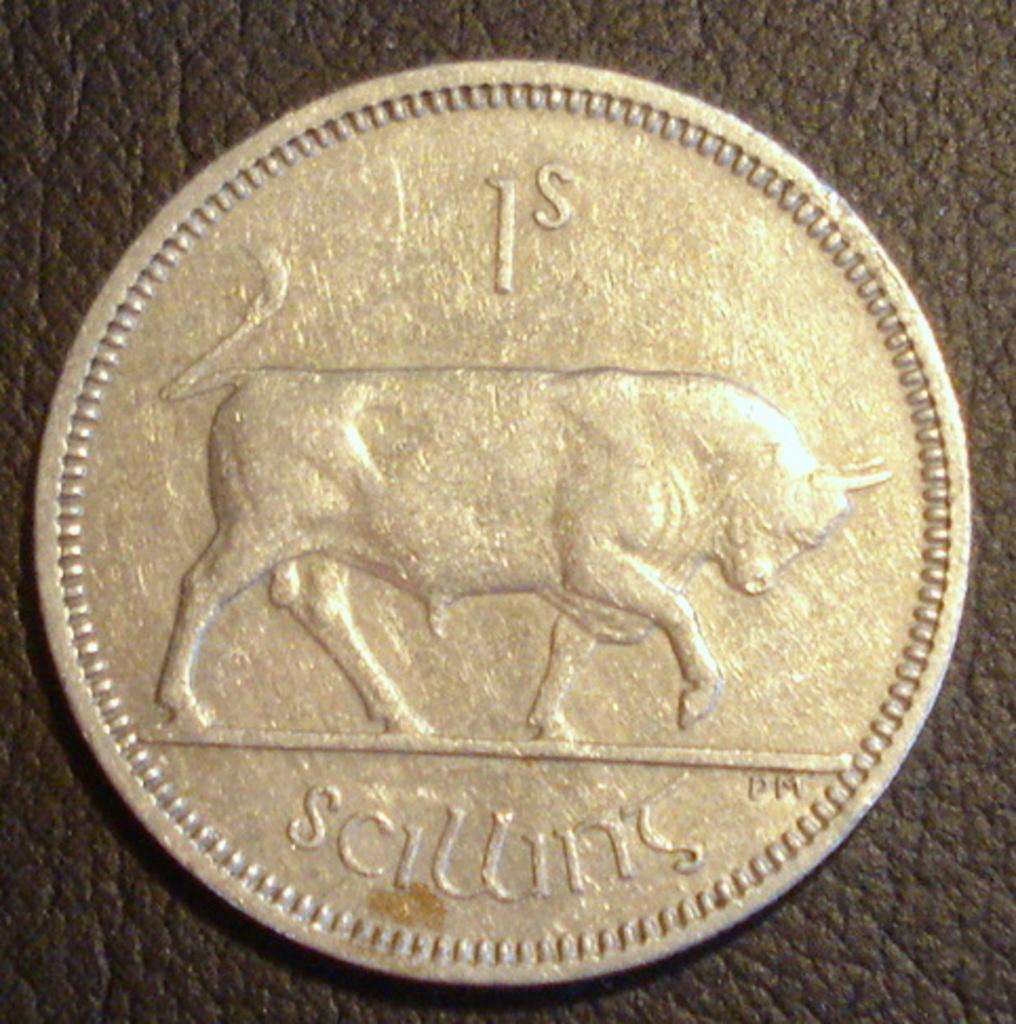What is depicted in the image? There is a picture of an animal in the image. What else can be seen in the image besides the animal? There is text on a coin in the image. What is visible in the background of the image? There is a wall in the background of the image. What action does the animal take in the image? The image is a still picture, so the animal is not taking any action. 